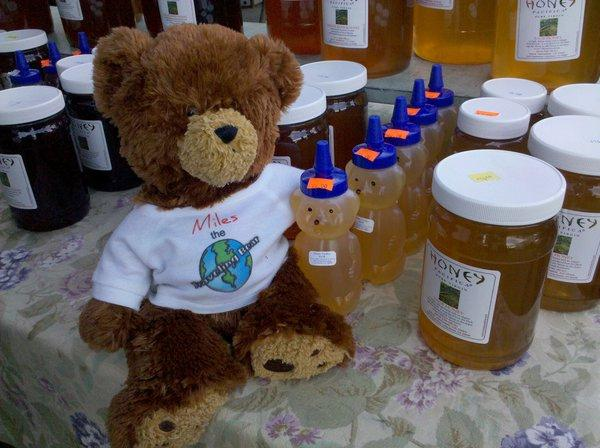What color are the tags on top of the honey dispensers?

Choices:
A) orange
B) white
C) pink
D) purple orange 